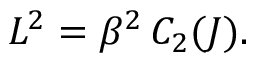<formula> <loc_0><loc_0><loc_500><loc_500>L ^ { 2 } = \beta ^ { 2 } \, C _ { 2 } ( J ) .</formula> 